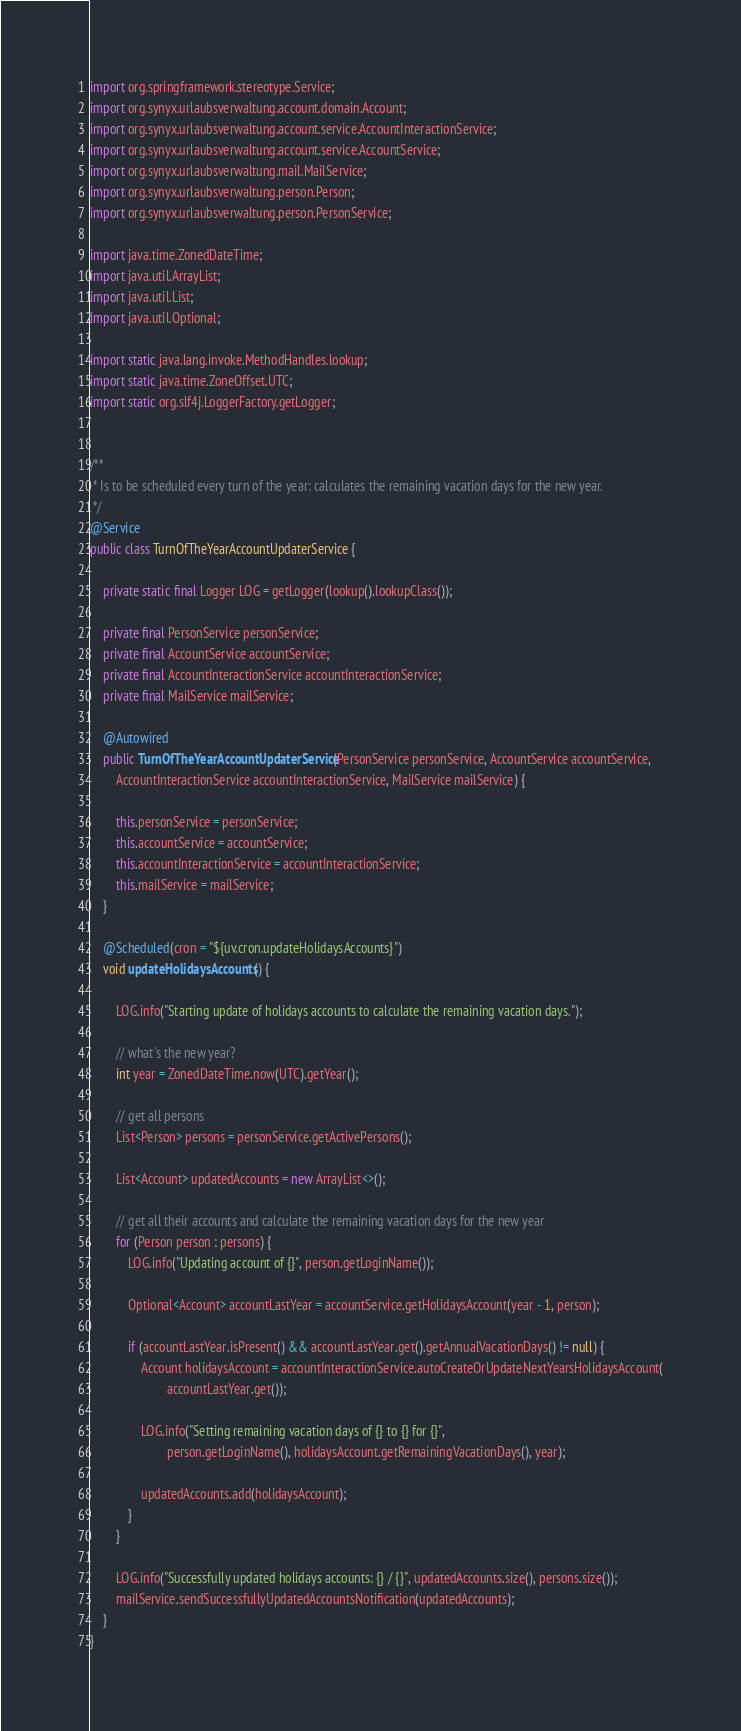Convert code to text. <code><loc_0><loc_0><loc_500><loc_500><_Java_>import org.springframework.stereotype.Service;
import org.synyx.urlaubsverwaltung.account.domain.Account;
import org.synyx.urlaubsverwaltung.account.service.AccountInteractionService;
import org.synyx.urlaubsverwaltung.account.service.AccountService;
import org.synyx.urlaubsverwaltung.mail.MailService;
import org.synyx.urlaubsverwaltung.person.Person;
import org.synyx.urlaubsverwaltung.person.PersonService;

import java.time.ZonedDateTime;
import java.util.ArrayList;
import java.util.List;
import java.util.Optional;

import static java.lang.invoke.MethodHandles.lookup;
import static java.time.ZoneOffset.UTC;
import static org.slf4j.LoggerFactory.getLogger;


/**
 * Is to be scheduled every turn of the year: calculates the remaining vacation days for the new year.
 */
@Service
public class TurnOfTheYearAccountUpdaterService {

    private static final Logger LOG = getLogger(lookup().lookupClass());

    private final PersonService personService;
    private final AccountService accountService;
    private final AccountInteractionService accountInteractionService;
    private final MailService mailService;

    @Autowired
    public TurnOfTheYearAccountUpdaterService(PersonService personService, AccountService accountService,
        AccountInteractionService accountInteractionService, MailService mailService) {

        this.personService = personService;
        this.accountService = accountService;
        this.accountInteractionService = accountInteractionService;
        this.mailService = mailService;
    }

    @Scheduled(cron = "${uv.cron.updateHolidaysAccounts}")
    void updateHolidaysAccounts() {

        LOG.info("Starting update of holidays accounts to calculate the remaining vacation days.");

        // what's the new year?
        int year = ZonedDateTime.now(UTC).getYear();

        // get all persons
        List<Person> persons = personService.getActivePersons();

        List<Account> updatedAccounts = new ArrayList<>();

        // get all their accounts and calculate the remaining vacation days for the new year
        for (Person person : persons) {
            LOG.info("Updating account of {}", person.getLoginName());

            Optional<Account> accountLastYear = accountService.getHolidaysAccount(year - 1, person);

            if (accountLastYear.isPresent() && accountLastYear.get().getAnnualVacationDays() != null) {
                Account holidaysAccount = accountInteractionService.autoCreateOrUpdateNextYearsHolidaysAccount(
                        accountLastYear.get());

                LOG.info("Setting remaining vacation days of {} to {} for {}",
                        person.getLoginName(), holidaysAccount.getRemainingVacationDays(), year);

                updatedAccounts.add(holidaysAccount);
            }
        }

        LOG.info("Successfully updated holidays accounts: {} / {}", updatedAccounts.size(), persons.size());
        mailService.sendSuccessfullyUpdatedAccountsNotification(updatedAccounts);
    }
}
</code> 